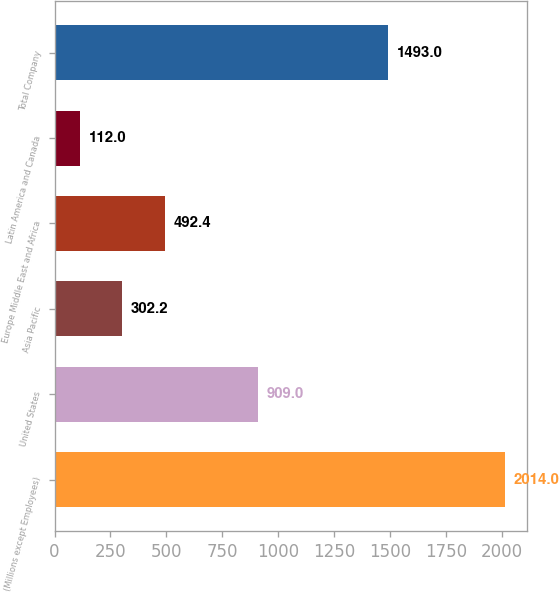Convert chart to OTSL. <chart><loc_0><loc_0><loc_500><loc_500><bar_chart><fcel>(Millions except Employees)<fcel>United States<fcel>Asia Pacific<fcel>Europe Middle East and Africa<fcel>Latin America and Canada<fcel>Total Company<nl><fcel>2014<fcel>909<fcel>302.2<fcel>492.4<fcel>112<fcel>1493<nl></chart> 